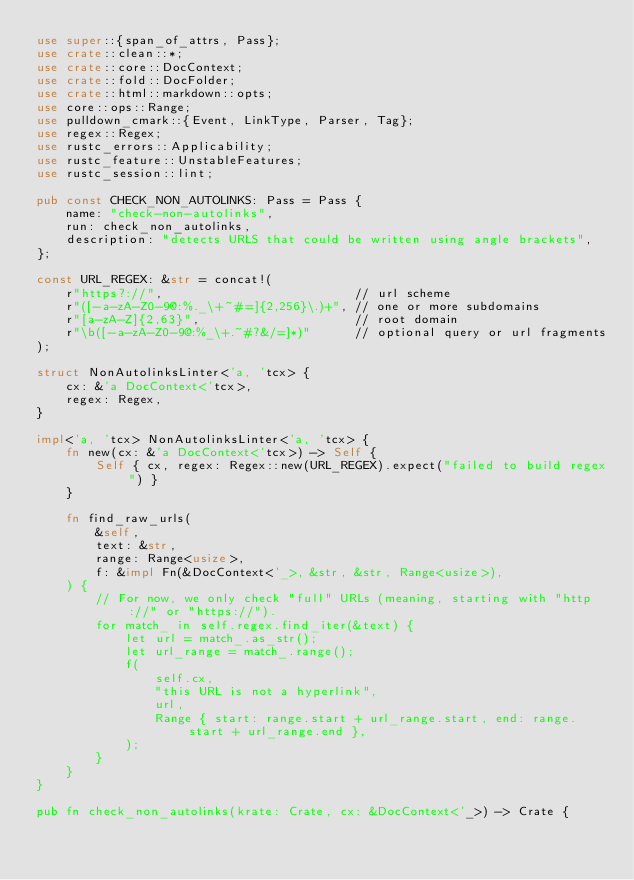Convert code to text. <code><loc_0><loc_0><loc_500><loc_500><_Rust_>use super::{span_of_attrs, Pass};
use crate::clean::*;
use crate::core::DocContext;
use crate::fold::DocFolder;
use crate::html::markdown::opts;
use core::ops::Range;
use pulldown_cmark::{Event, LinkType, Parser, Tag};
use regex::Regex;
use rustc_errors::Applicability;
use rustc_feature::UnstableFeatures;
use rustc_session::lint;

pub const CHECK_NON_AUTOLINKS: Pass = Pass {
    name: "check-non-autolinks",
    run: check_non_autolinks,
    description: "detects URLS that could be written using angle brackets",
};

const URL_REGEX: &str = concat!(
    r"https?://",                          // url scheme
    r"([-a-zA-Z0-9@:%._\+~#=]{2,256}\.)+", // one or more subdomains
    r"[a-zA-Z]{2,63}",                     // root domain
    r"\b([-a-zA-Z0-9@:%_\+.~#?&/=]*)"      // optional query or url fragments
);

struct NonAutolinksLinter<'a, 'tcx> {
    cx: &'a DocContext<'tcx>,
    regex: Regex,
}

impl<'a, 'tcx> NonAutolinksLinter<'a, 'tcx> {
    fn new(cx: &'a DocContext<'tcx>) -> Self {
        Self { cx, regex: Regex::new(URL_REGEX).expect("failed to build regex") }
    }

    fn find_raw_urls(
        &self,
        text: &str,
        range: Range<usize>,
        f: &impl Fn(&DocContext<'_>, &str, &str, Range<usize>),
    ) {
        // For now, we only check "full" URLs (meaning, starting with "http://" or "https://").
        for match_ in self.regex.find_iter(&text) {
            let url = match_.as_str();
            let url_range = match_.range();
            f(
                self.cx,
                "this URL is not a hyperlink",
                url,
                Range { start: range.start + url_range.start, end: range.start + url_range.end },
            );
        }
    }
}

pub fn check_non_autolinks(krate: Crate, cx: &DocContext<'_>) -> Crate {</code> 